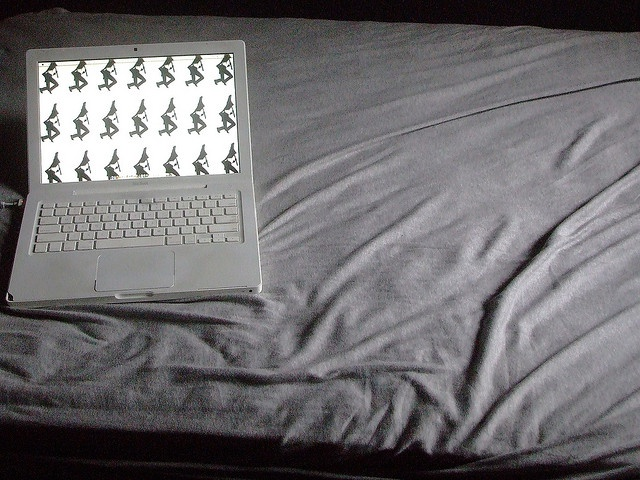Describe the objects in this image and their specific colors. I can see bed in gray and black tones and laptop in black, darkgray, white, and gray tones in this image. 